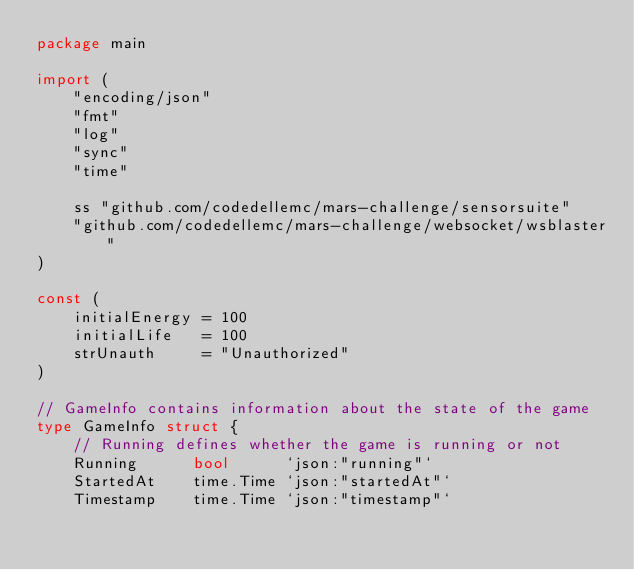Convert code to text. <code><loc_0><loc_0><loc_500><loc_500><_Go_>package main

import (
	"encoding/json"
	"fmt"
	"log"
	"sync"
	"time"

	ss "github.com/codedellemc/mars-challenge/sensorsuite"
	"github.com/codedellemc/mars-challenge/websocket/wsblaster"
)

const (
	initialEnergy = 100
	initialLife   = 100
	strUnauth     = "Unauthorized"
)

// GameInfo contains information about the state of the game
type GameInfo struct {
	// Running defines whether the game is running or not
	Running      bool      `json:"running"`
	StartedAt    time.Time `json:"startedAt"`
	Timestamp    time.Time `json:"timestamp"`</code> 